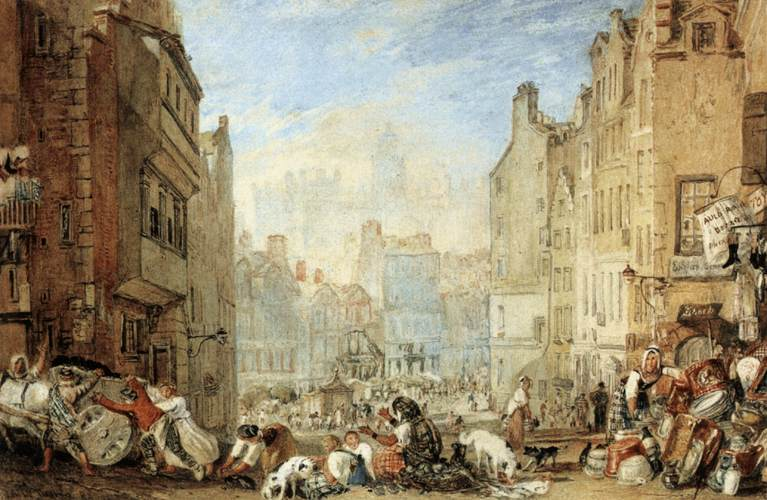What could be the significance of the dogs in the painting? The presence of dogs in the painting adds a layer of warmth and realism to the scene. They might represent loyalty and companionship, common themes in daily human life, or they could simply be part of the bustling street life, scavenging for food scraps and adding to the chaotic charm of the marketplace. Their interactions with the people also highlight the harmonious coexistence of humans and animals in urban environments. 